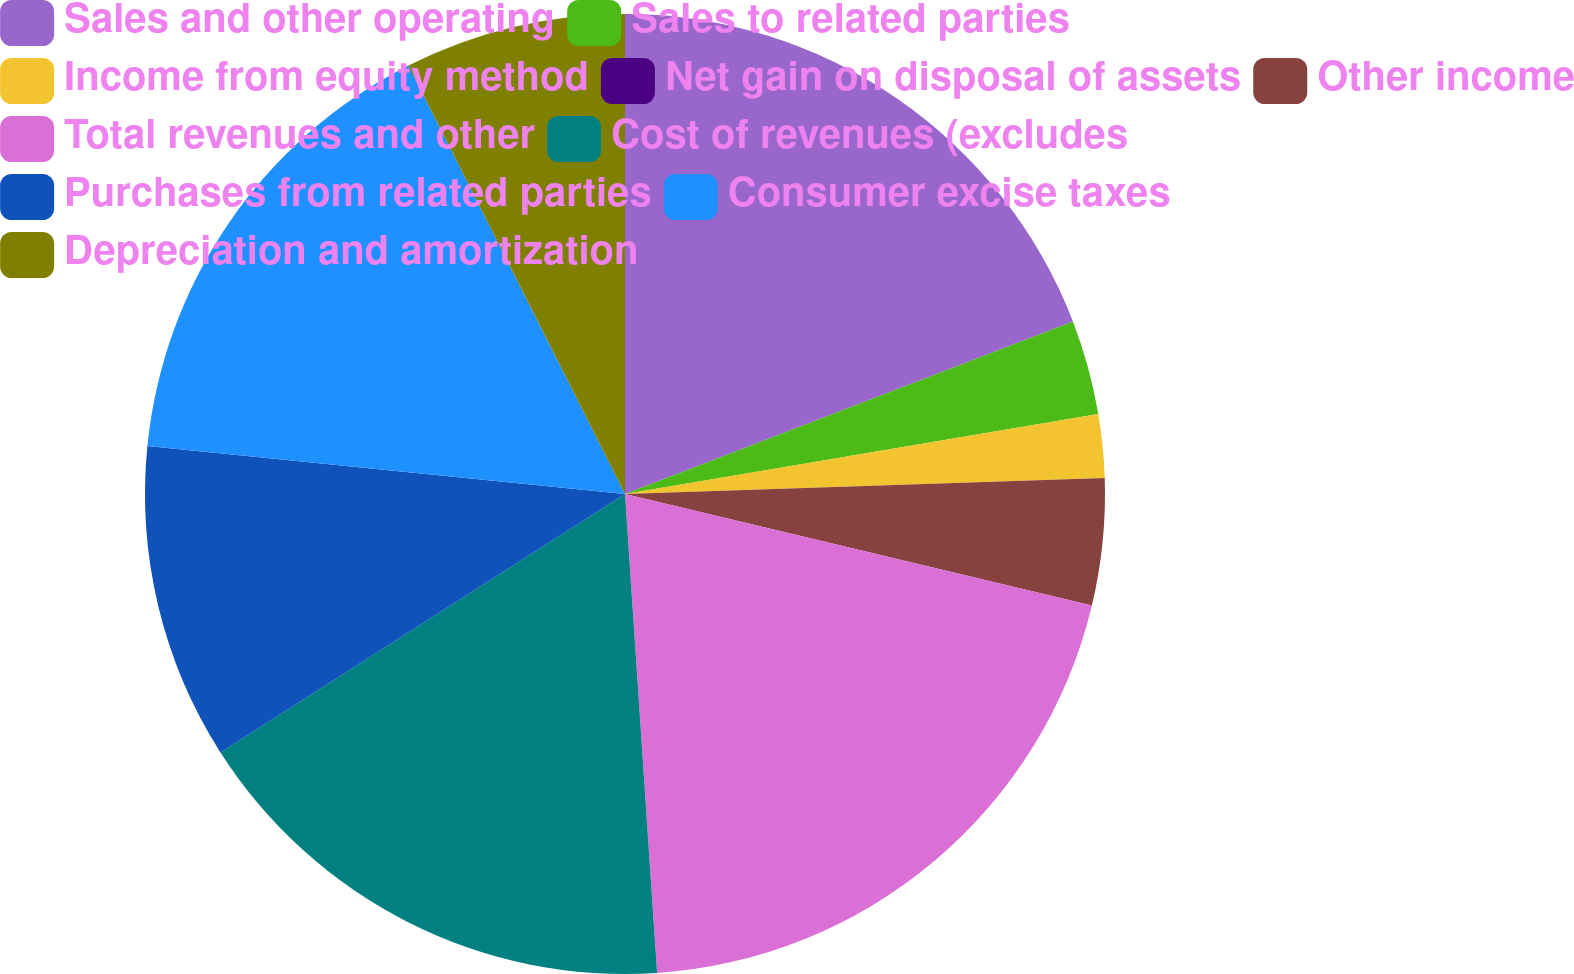<chart> <loc_0><loc_0><loc_500><loc_500><pie_chart><fcel>Sales and other operating<fcel>Sales to related parties<fcel>Income from equity method<fcel>Net gain on disposal of assets<fcel>Other income<fcel>Total revenues and other<fcel>Cost of revenues (excludes<fcel>Purchases from related parties<fcel>Consumer excise taxes<fcel>Depreciation and amortization<nl><fcel>19.15%<fcel>3.19%<fcel>2.13%<fcel>0.0%<fcel>4.26%<fcel>20.21%<fcel>17.02%<fcel>10.64%<fcel>15.96%<fcel>7.45%<nl></chart> 